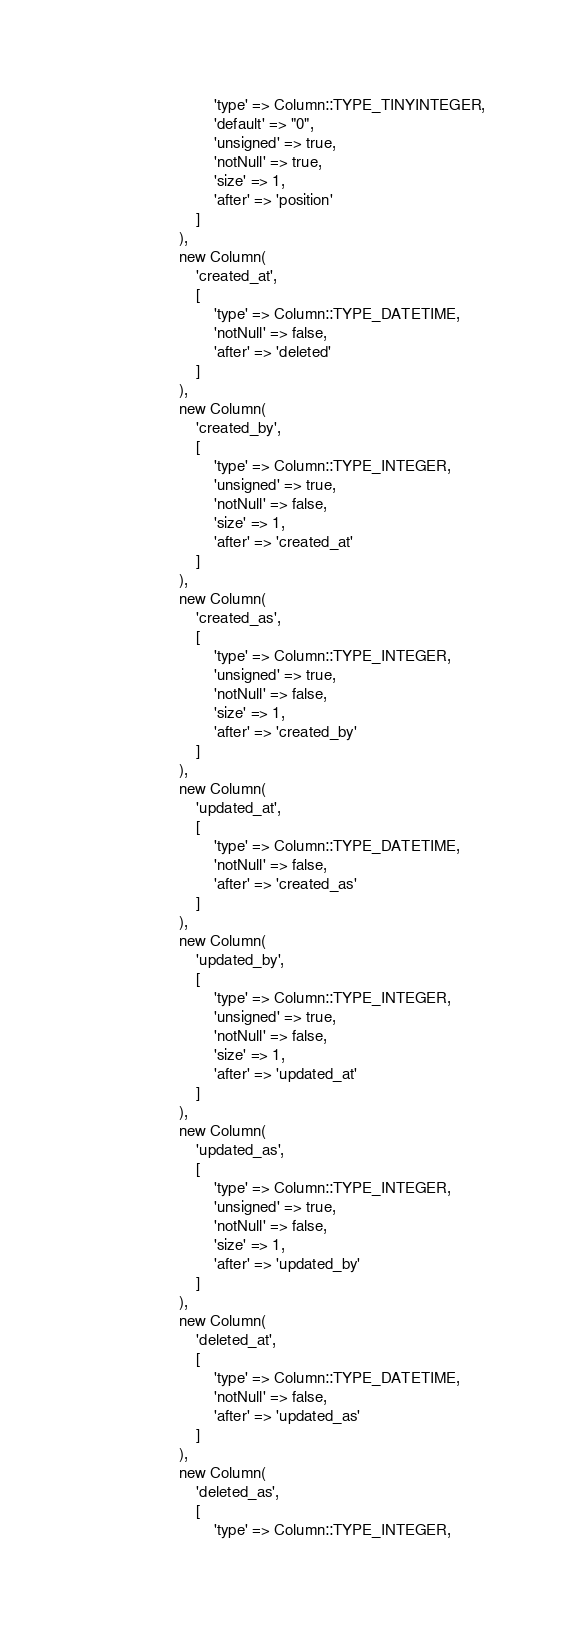<code> <loc_0><loc_0><loc_500><loc_500><_PHP_>                            'type' => Column::TYPE_TINYINTEGER,
                            'default' => "0",
                            'unsigned' => true,
                            'notNull' => true,
                            'size' => 1,
                            'after' => 'position'
                        ]
                    ),
                    new Column(
                        'created_at',
                        [
                            'type' => Column::TYPE_DATETIME,
                            'notNull' => false,
                            'after' => 'deleted'
                        ]
                    ),
                    new Column(
                        'created_by',
                        [
                            'type' => Column::TYPE_INTEGER,
                            'unsigned' => true,
                            'notNull' => false,
                            'size' => 1,
                            'after' => 'created_at'
                        ]
                    ),
                    new Column(
                        'created_as',
                        [
                            'type' => Column::TYPE_INTEGER,
                            'unsigned' => true,
                            'notNull' => false,
                            'size' => 1,
                            'after' => 'created_by'
                        ]
                    ),
                    new Column(
                        'updated_at',
                        [
                            'type' => Column::TYPE_DATETIME,
                            'notNull' => false,
                            'after' => 'created_as'
                        ]
                    ),
                    new Column(
                        'updated_by',
                        [
                            'type' => Column::TYPE_INTEGER,
                            'unsigned' => true,
                            'notNull' => false,
                            'size' => 1,
                            'after' => 'updated_at'
                        ]
                    ),
                    new Column(
                        'updated_as',
                        [
                            'type' => Column::TYPE_INTEGER,
                            'unsigned' => true,
                            'notNull' => false,
                            'size' => 1,
                            'after' => 'updated_by'
                        ]
                    ),
                    new Column(
                        'deleted_at',
                        [
                            'type' => Column::TYPE_DATETIME,
                            'notNull' => false,
                            'after' => 'updated_as'
                        ]
                    ),
                    new Column(
                        'deleted_as',
                        [
                            'type' => Column::TYPE_INTEGER,</code> 